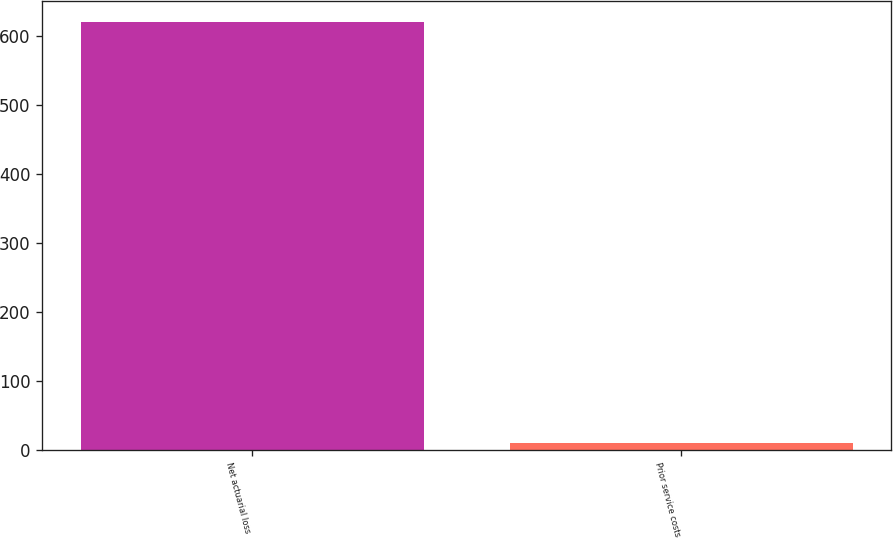Convert chart to OTSL. <chart><loc_0><loc_0><loc_500><loc_500><bar_chart><fcel>Net actuarial loss<fcel>Prior service costs<nl><fcel>620<fcel>10<nl></chart> 